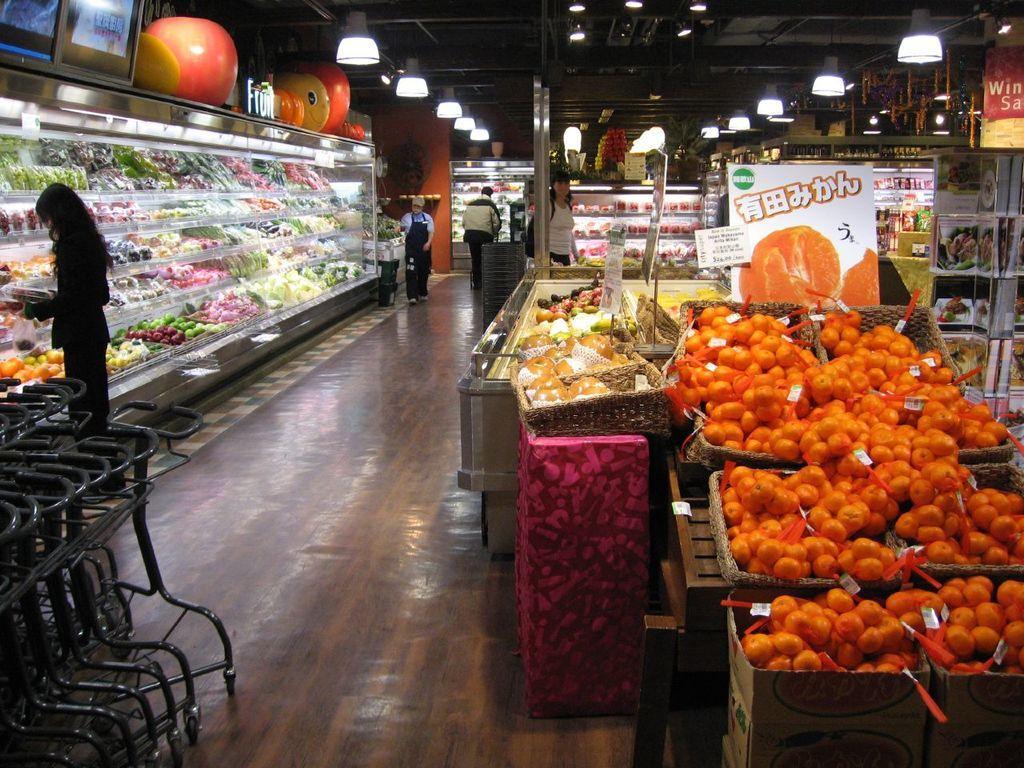Can you describe this image briefly? In this image there is one person standing on the left side of this image and there are some persons standing in middle of this image. There are some fruits kept on a table on the right side of this image and there are some fruits and food items are kept on the left side of this image. There are some lights arranged on the top of this image. There is a floor in the bottom of this image. There is a trolley on the left side of this image. 